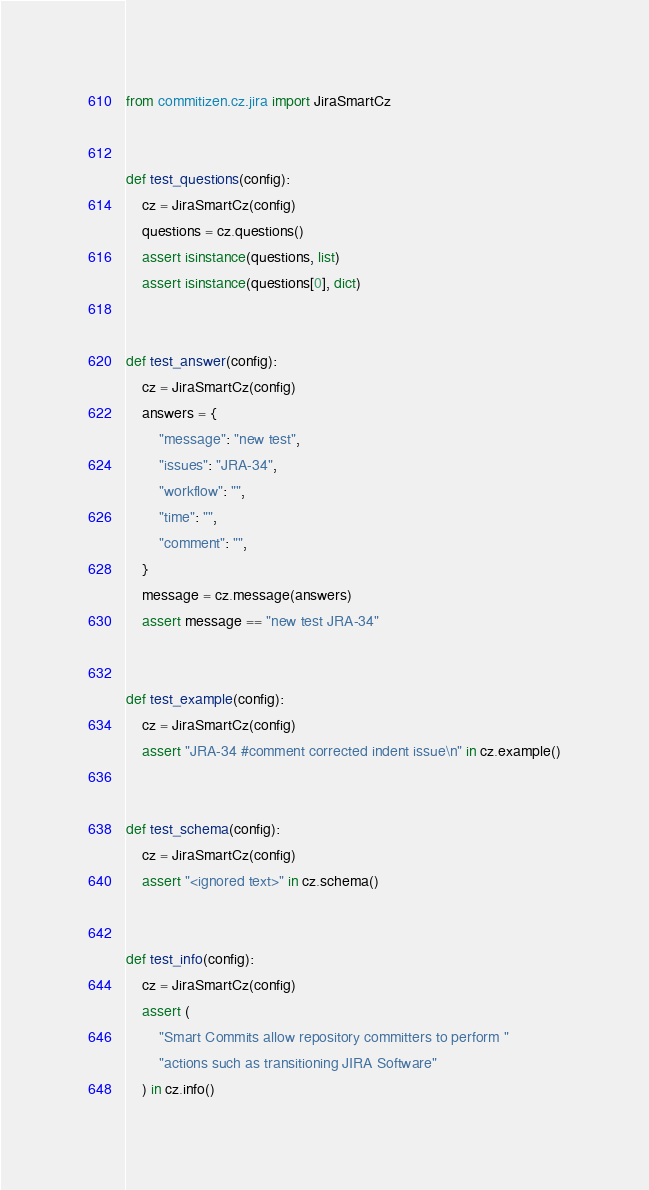<code> <loc_0><loc_0><loc_500><loc_500><_Python_>from commitizen.cz.jira import JiraSmartCz


def test_questions(config):
    cz = JiraSmartCz(config)
    questions = cz.questions()
    assert isinstance(questions, list)
    assert isinstance(questions[0], dict)


def test_answer(config):
    cz = JiraSmartCz(config)
    answers = {
        "message": "new test",
        "issues": "JRA-34",
        "workflow": "",
        "time": "",
        "comment": "",
    }
    message = cz.message(answers)
    assert message == "new test JRA-34"


def test_example(config):
    cz = JiraSmartCz(config)
    assert "JRA-34 #comment corrected indent issue\n" in cz.example()


def test_schema(config):
    cz = JiraSmartCz(config)
    assert "<ignored text>" in cz.schema()


def test_info(config):
    cz = JiraSmartCz(config)
    assert (
        "Smart Commits allow repository committers to perform "
        "actions such as transitioning JIRA Software"
    ) in cz.info()
</code> 